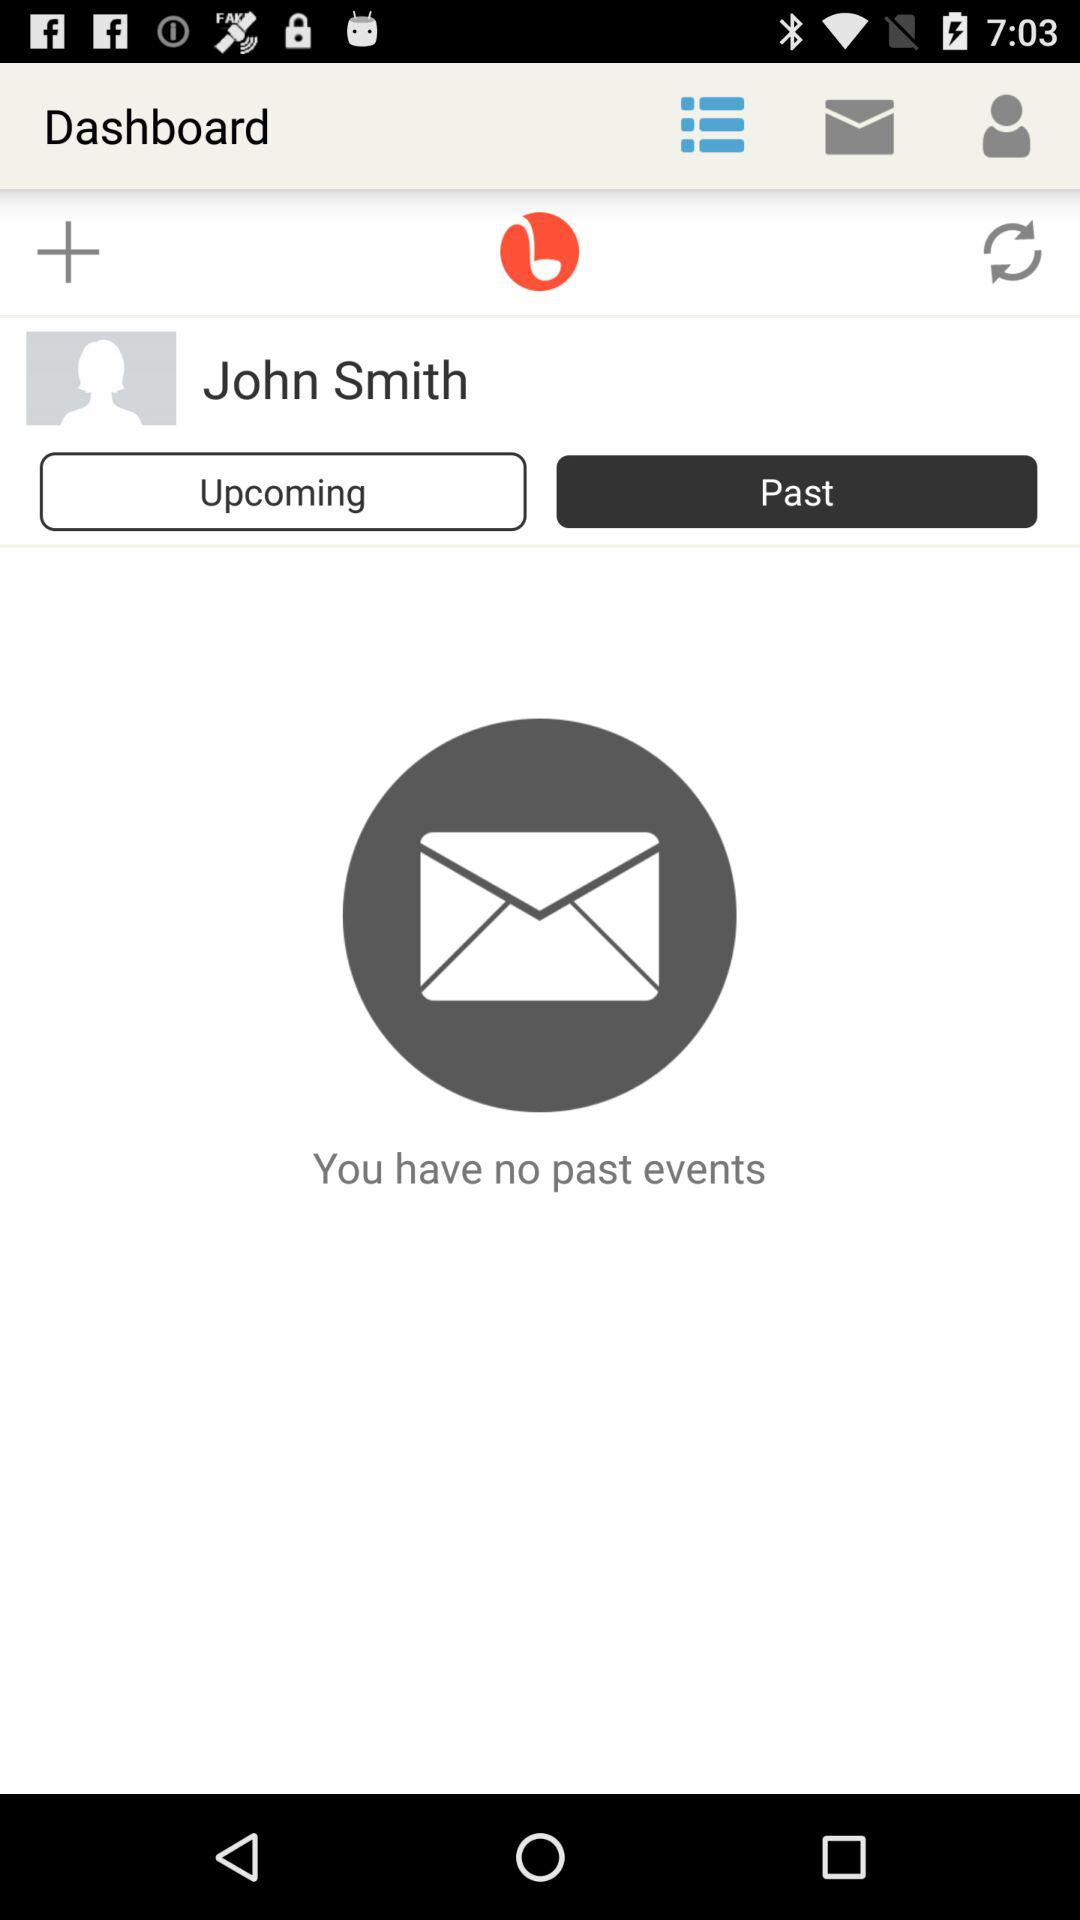Which tab is selected? The selected tab is "Past". 